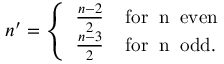Convert formula to latex. <formula><loc_0><loc_0><loc_500><loc_500>n ^ { \prime } = \left \{ \begin{array} { l } { { \frac { n - 2 } { 2 } \, f o r \, n \, e v e n } } \\ { { \frac { n - 3 } { 2 } \, f o r \, n \, o d d . } } \end{array}</formula> 